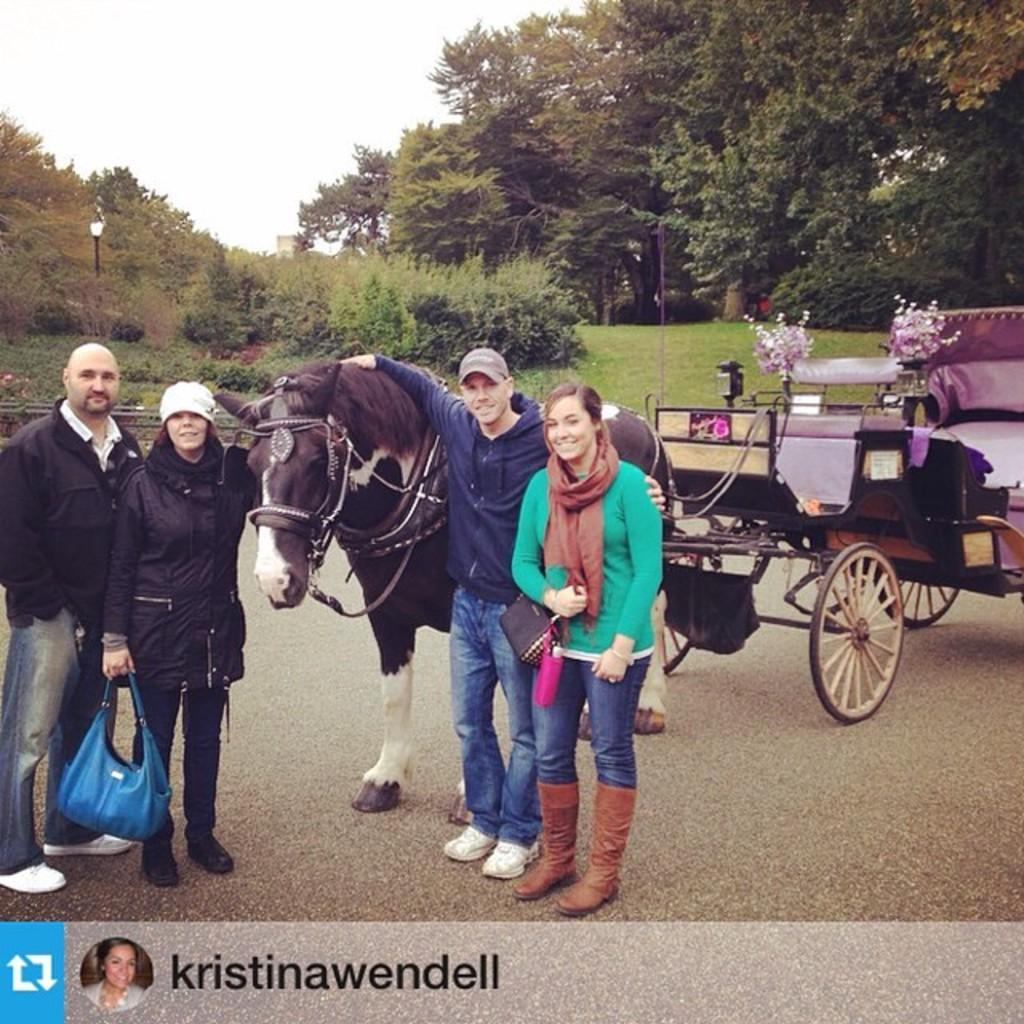Can you describe this image briefly? This image is taken outdoors. At the bottom of the image there is a road. In the middle of the image there is a cart with a horse and there are two men and two women standing on the road. In the background there are a few trees and plants and there is a ground with grass on it. At the top of the image there is a sky. 